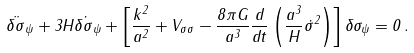Convert formula to latex. <formula><loc_0><loc_0><loc_500><loc_500>\ddot { \delta \sigma } _ { \psi } + 3 H \dot { \delta \sigma } _ { \psi } + \left [ \frac { k ^ { 2 } } { a ^ { 2 } } + V _ { \sigma \sigma } - \frac { 8 \pi G } { a ^ { 3 } } \frac { d } { d t } \left ( \frac { a ^ { 3 } } { H } \dot { \sigma } ^ { 2 } \right ) \right ] \delta \sigma _ { \psi } = 0 \, .</formula> 